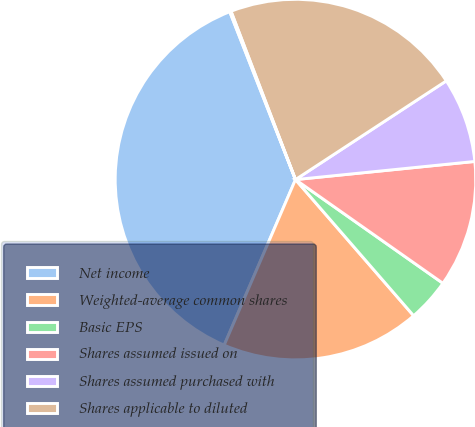<chart> <loc_0><loc_0><loc_500><loc_500><pie_chart><fcel>Net income<fcel>Weighted-average common shares<fcel>Basic EPS<fcel>Shares assumed issued on<fcel>Shares assumed purchased with<fcel>Shares applicable to diluted<fcel>Diluted EPS<nl><fcel>37.59%<fcel>17.85%<fcel>3.87%<fcel>11.36%<fcel>7.62%<fcel>21.6%<fcel>0.12%<nl></chart> 